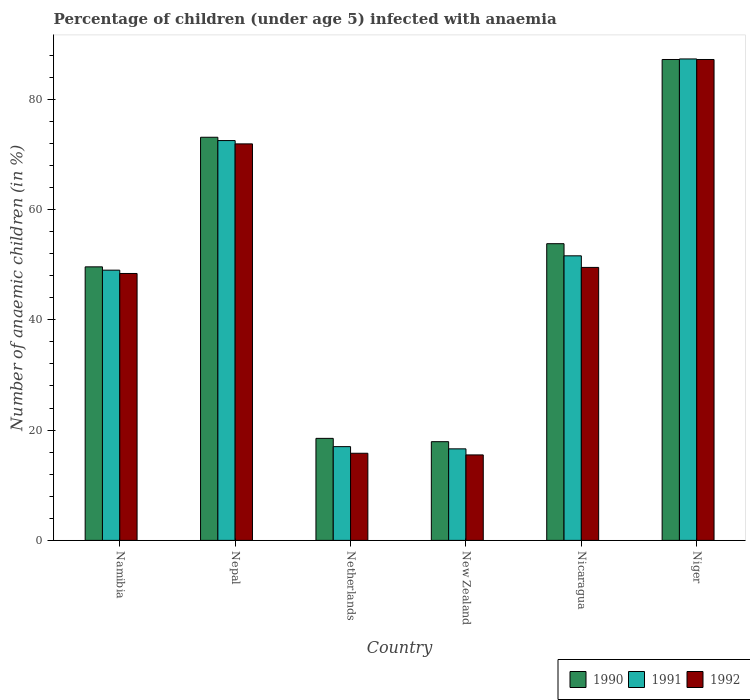How many different coloured bars are there?
Keep it short and to the point. 3. Are the number of bars on each tick of the X-axis equal?
Your answer should be compact. Yes. How many bars are there on the 6th tick from the left?
Offer a terse response. 3. What is the label of the 4th group of bars from the left?
Your answer should be very brief. New Zealand. Across all countries, what is the maximum percentage of children infected with anaemia in in 1992?
Ensure brevity in your answer.  87.2. Across all countries, what is the minimum percentage of children infected with anaemia in in 1992?
Ensure brevity in your answer.  15.5. In which country was the percentage of children infected with anaemia in in 1992 maximum?
Ensure brevity in your answer.  Niger. In which country was the percentage of children infected with anaemia in in 1991 minimum?
Your answer should be very brief. New Zealand. What is the total percentage of children infected with anaemia in in 1990 in the graph?
Offer a very short reply. 300.1. What is the difference between the percentage of children infected with anaemia in in 1991 in Nepal and that in Nicaragua?
Provide a succinct answer. 20.9. What is the difference between the percentage of children infected with anaemia in in 1990 in Nicaragua and the percentage of children infected with anaemia in in 1991 in Netherlands?
Keep it short and to the point. 36.8. What is the difference between the percentage of children infected with anaemia in of/in 1991 and percentage of children infected with anaemia in of/in 1990 in Netherlands?
Make the answer very short. -1.5. What is the ratio of the percentage of children infected with anaemia in in 1992 in Netherlands to that in Nicaragua?
Your answer should be very brief. 0.32. What is the difference between the highest and the second highest percentage of children infected with anaemia in in 1990?
Provide a succinct answer. 19.3. What is the difference between the highest and the lowest percentage of children infected with anaemia in in 1990?
Your answer should be compact. 69.3. In how many countries, is the percentage of children infected with anaemia in in 1990 greater than the average percentage of children infected with anaemia in in 1990 taken over all countries?
Provide a succinct answer. 3. Is the sum of the percentage of children infected with anaemia in in 1991 in Netherlands and New Zealand greater than the maximum percentage of children infected with anaemia in in 1992 across all countries?
Ensure brevity in your answer.  No. What does the 1st bar from the left in New Zealand represents?
Give a very brief answer. 1990. What does the 1st bar from the right in Namibia represents?
Your answer should be compact. 1992. Are all the bars in the graph horizontal?
Offer a very short reply. No. How many countries are there in the graph?
Your response must be concise. 6. What is the difference between two consecutive major ticks on the Y-axis?
Give a very brief answer. 20. Does the graph contain grids?
Your answer should be very brief. No. How are the legend labels stacked?
Offer a very short reply. Horizontal. What is the title of the graph?
Provide a short and direct response. Percentage of children (under age 5) infected with anaemia. What is the label or title of the Y-axis?
Your response must be concise. Number of anaemic children (in %). What is the Number of anaemic children (in %) of 1990 in Namibia?
Offer a terse response. 49.6. What is the Number of anaemic children (in %) in 1991 in Namibia?
Your answer should be compact. 49. What is the Number of anaemic children (in %) of 1992 in Namibia?
Your answer should be compact. 48.4. What is the Number of anaemic children (in %) of 1990 in Nepal?
Provide a short and direct response. 73.1. What is the Number of anaemic children (in %) of 1991 in Nepal?
Offer a terse response. 72.5. What is the Number of anaemic children (in %) in 1992 in Nepal?
Make the answer very short. 71.9. What is the Number of anaemic children (in %) of 1991 in Netherlands?
Make the answer very short. 17. What is the Number of anaemic children (in %) in 1992 in Netherlands?
Provide a succinct answer. 15.8. What is the Number of anaemic children (in %) in 1990 in New Zealand?
Provide a succinct answer. 17.9. What is the Number of anaemic children (in %) in 1992 in New Zealand?
Ensure brevity in your answer.  15.5. What is the Number of anaemic children (in %) of 1990 in Nicaragua?
Your answer should be very brief. 53.8. What is the Number of anaemic children (in %) in 1991 in Nicaragua?
Your response must be concise. 51.6. What is the Number of anaemic children (in %) of 1992 in Nicaragua?
Provide a succinct answer. 49.5. What is the Number of anaemic children (in %) in 1990 in Niger?
Keep it short and to the point. 87.2. What is the Number of anaemic children (in %) in 1991 in Niger?
Your answer should be compact. 87.3. What is the Number of anaemic children (in %) of 1992 in Niger?
Provide a succinct answer. 87.2. Across all countries, what is the maximum Number of anaemic children (in %) in 1990?
Provide a short and direct response. 87.2. Across all countries, what is the maximum Number of anaemic children (in %) in 1991?
Your answer should be compact. 87.3. Across all countries, what is the maximum Number of anaemic children (in %) in 1992?
Your answer should be very brief. 87.2. Across all countries, what is the minimum Number of anaemic children (in %) in 1991?
Keep it short and to the point. 16.6. What is the total Number of anaemic children (in %) of 1990 in the graph?
Provide a succinct answer. 300.1. What is the total Number of anaemic children (in %) of 1991 in the graph?
Keep it short and to the point. 294. What is the total Number of anaemic children (in %) in 1992 in the graph?
Your answer should be very brief. 288.3. What is the difference between the Number of anaemic children (in %) of 1990 in Namibia and that in Nepal?
Provide a succinct answer. -23.5. What is the difference between the Number of anaemic children (in %) of 1991 in Namibia and that in Nepal?
Keep it short and to the point. -23.5. What is the difference between the Number of anaemic children (in %) of 1992 in Namibia and that in Nepal?
Your answer should be compact. -23.5. What is the difference between the Number of anaemic children (in %) of 1990 in Namibia and that in Netherlands?
Your response must be concise. 31.1. What is the difference between the Number of anaemic children (in %) in 1992 in Namibia and that in Netherlands?
Your answer should be very brief. 32.6. What is the difference between the Number of anaemic children (in %) in 1990 in Namibia and that in New Zealand?
Provide a short and direct response. 31.7. What is the difference between the Number of anaemic children (in %) of 1991 in Namibia and that in New Zealand?
Offer a terse response. 32.4. What is the difference between the Number of anaemic children (in %) of 1992 in Namibia and that in New Zealand?
Ensure brevity in your answer.  32.9. What is the difference between the Number of anaemic children (in %) of 1991 in Namibia and that in Nicaragua?
Your response must be concise. -2.6. What is the difference between the Number of anaemic children (in %) in 1992 in Namibia and that in Nicaragua?
Ensure brevity in your answer.  -1.1. What is the difference between the Number of anaemic children (in %) of 1990 in Namibia and that in Niger?
Your response must be concise. -37.6. What is the difference between the Number of anaemic children (in %) in 1991 in Namibia and that in Niger?
Keep it short and to the point. -38.3. What is the difference between the Number of anaemic children (in %) of 1992 in Namibia and that in Niger?
Offer a terse response. -38.8. What is the difference between the Number of anaemic children (in %) in 1990 in Nepal and that in Netherlands?
Offer a terse response. 54.6. What is the difference between the Number of anaemic children (in %) in 1991 in Nepal and that in Netherlands?
Your response must be concise. 55.5. What is the difference between the Number of anaemic children (in %) of 1992 in Nepal and that in Netherlands?
Provide a succinct answer. 56.1. What is the difference between the Number of anaemic children (in %) in 1990 in Nepal and that in New Zealand?
Keep it short and to the point. 55.2. What is the difference between the Number of anaemic children (in %) in 1991 in Nepal and that in New Zealand?
Provide a short and direct response. 55.9. What is the difference between the Number of anaemic children (in %) in 1992 in Nepal and that in New Zealand?
Keep it short and to the point. 56.4. What is the difference between the Number of anaemic children (in %) in 1990 in Nepal and that in Nicaragua?
Provide a succinct answer. 19.3. What is the difference between the Number of anaemic children (in %) of 1991 in Nepal and that in Nicaragua?
Provide a succinct answer. 20.9. What is the difference between the Number of anaemic children (in %) of 1992 in Nepal and that in Nicaragua?
Provide a succinct answer. 22.4. What is the difference between the Number of anaemic children (in %) of 1990 in Nepal and that in Niger?
Your answer should be compact. -14.1. What is the difference between the Number of anaemic children (in %) in 1991 in Nepal and that in Niger?
Give a very brief answer. -14.8. What is the difference between the Number of anaemic children (in %) in 1992 in Nepal and that in Niger?
Offer a terse response. -15.3. What is the difference between the Number of anaemic children (in %) of 1990 in Netherlands and that in New Zealand?
Your response must be concise. 0.6. What is the difference between the Number of anaemic children (in %) in 1990 in Netherlands and that in Nicaragua?
Offer a terse response. -35.3. What is the difference between the Number of anaemic children (in %) in 1991 in Netherlands and that in Nicaragua?
Keep it short and to the point. -34.6. What is the difference between the Number of anaemic children (in %) of 1992 in Netherlands and that in Nicaragua?
Make the answer very short. -33.7. What is the difference between the Number of anaemic children (in %) in 1990 in Netherlands and that in Niger?
Your answer should be compact. -68.7. What is the difference between the Number of anaemic children (in %) of 1991 in Netherlands and that in Niger?
Ensure brevity in your answer.  -70.3. What is the difference between the Number of anaemic children (in %) of 1992 in Netherlands and that in Niger?
Give a very brief answer. -71.4. What is the difference between the Number of anaemic children (in %) of 1990 in New Zealand and that in Nicaragua?
Your answer should be compact. -35.9. What is the difference between the Number of anaemic children (in %) in 1991 in New Zealand and that in Nicaragua?
Your response must be concise. -35. What is the difference between the Number of anaemic children (in %) in 1992 in New Zealand and that in Nicaragua?
Keep it short and to the point. -34. What is the difference between the Number of anaemic children (in %) in 1990 in New Zealand and that in Niger?
Keep it short and to the point. -69.3. What is the difference between the Number of anaemic children (in %) in 1991 in New Zealand and that in Niger?
Provide a short and direct response. -70.7. What is the difference between the Number of anaemic children (in %) of 1992 in New Zealand and that in Niger?
Your answer should be very brief. -71.7. What is the difference between the Number of anaemic children (in %) of 1990 in Nicaragua and that in Niger?
Your answer should be very brief. -33.4. What is the difference between the Number of anaemic children (in %) of 1991 in Nicaragua and that in Niger?
Your response must be concise. -35.7. What is the difference between the Number of anaemic children (in %) in 1992 in Nicaragua and that in Niger?
Offer a very short reply. -37.7. What is the difference between the Number of anaemic children (in %) of 1990 in Namibia and the Number of anaemic children (in %) of 1991 in Nepal?
Provide a succinct answer. -22.9. What is the difference between the Number of anaemic children (in %) in 1990 in Namibia and the Number of anaemic children (in %) in 1992 in Nepal?
Keep it short and to the point. -22.3. What is the difference between the Number of anaemic children (in %) in 1991 in Namibia and the Number of anaemic children (in %) in 1992 in Nepal?
Make the answer very short. -22.9. What is the difference between the Number of anaemic children (in %) of 1990 in Namibia and the Number of anaemic children (in %) of 1991 in Netherlands?
Keep it short and to the point. 32.6. What is the difference between the Number of anaemic children (in %) in 1990 in Namibia and the Number of anaemic children (in %) in 1992 in Netherlands?
Offer a terse response. 33.8. What is the difference between the Number of anaemic children (in %) in 1991 in Namibia and the Number of anaemic children (in %) in 1992 in Netherlands?
Your answer should be compact. 33.2. What is the difference between the Number of anaemic children (in %) of 1990 in Namibia and the Number of anaemic children (in %) of 1992 in New Zealand?
Offer a terse response. 34.1. What is the difference between the Number of anaemic children (in %) in 1991 in Namibia and the Number of anaemic children (in %) in 1992 in New Zealand?
Ensure brevity in your answer.  33.5. What is the difference between the Number of anaemic children (in %) of 1990 in Namibia and the Number of anaemic children (in %) of 1991 in Nicaragua?
Keep it short and to the point. -2. What is the difference between the Number of anaemic children (in %) of 1990 in Namibia and the Number of anaemic children (in %) of 1991 in Niger?
Provide a succinct answer. -37.7. What is the difference between the Number of anaemic children (in %) of 1990 in Namibia and the Number of anaemic children (in %) of 1992 in Niger?
Provide a short and direct response. -37.6. What is the difference between the Number of anaemic children (in %) of 1991 in Namibia and the Number of anaemic children (in %) of 1992 in Niger?
Give a very brief answer. -38.2. What is the difference between the Number of anaemic children (in %) in 1990 in Nepal and the Number of anaemic children (in %) in 1991 in Netherlands?
Offer a very short reply. 56.1. What is the difference between the Number of anaemic children (in %) in 1990 in Nepal and the Number of anaemic children (in %) in 1992 in Netherlands?
Make the answer very short. 57.3. What is the difference between the Number of anaemic children (in %) in 1991 in Nepal and the Number of anaemic children (in %) in 1992 in Netherlands?
Give a very brief answer. 56.7. What is the difference between the Number of anaemic children (in %) of 1990 in Nepal and the Number of anaemic children (in %) of 1991 in New Zealand?
Your answer should be compact. 56.5. What is the difference between the Number of anaemic children (in %) in 1990 in Nepal and the Number of anaemic children (in %) in 1992 in New Zealand?
Keep it short and to the point. 57.6. What is the difference between the Number of anaemic children (in %) of 1991 in Nepal and the Number of anaemic children (in %) of 1992 in New Zealand?
Provide a short and direct response. 57. What is the difference between the Number of anaemic children (in %) of 1990 in Nepal and the Number of anaemic children (in %) of 1991 in Nicaragua?
Provide a short and direct response. 21.5. What is the difference between the Number of anaemic children (in %) of 1990 in Nepal and the Number of anaemic children (in %) of 1992 in Nicaragua?
Your response must be concise. 23.6. What is the difference between the Number of anaemic children (in %) in 1991 in Nepal and the Number of anaemic children (in %) in 1992 in Nicaragua?
Offer a terse response. 23. What is the difference between the Number of anaemic children (in %) in 1990 in Nepal and the Number of anaemic children (in %) in 1992 in Niger?
Make the answer very short. -14.1. What is the difference between the Number of anaemic children (in %) in 1991 in Nepal and the Number of anaemic children (in %) in 1992 in Niger?
Your response must be concise. -14.7. What is the difference between the Number of anaemic children (in %) of 1990 in Netherlands and the Number of anaemic children (in %) of 1992 in New Zealand?
Provide a short and direct response. 3. What is the difference between the Number of anaemic children (in %) in 1991 in Netherlands and the Number of anaemic children (in %) in 1992 in New Zealand?
Your response must be concise. 1.5. What is the difference between the Number of anaemic children (in %) in 1990 in Netherlands and the Number of anaemic children (in %) in 1991 in Nicaragua?
Keep it short and to the point. -33.1. What is the difference between the Number of anaemic children (in %) in 1990 in Netherlands and the Number of anaemic children (in %) in 1992 in Nicaragua?
Your answer should be very brief. -31. What is the difference between the Number of anaemic children (in %) in 1991 in Netherlands and the Number of anaemic children (in %) in 1992 in Nicaragua?
Provide a succinct answer. -32.5. What is the difference between the Number of anaemic children (in %) in 1990 in Netherlands and the Number of anaemic children (in %) in 1991 in Niger?
Provide a succinct answer. -68.8. What is the difference between the Number of anaemic children (in %) of 1990 in Netherlands and the Number of anaemic children (in %) of 1992 in Niger?
Make the answer very short. -68.7. What is the difference between the Number of anaemic children (in %) in 1991 in Netherlands and the Number of anaemic children (in %) in 1992 in Niger?
Ensure brevity in your answer.  -70.2. What is the difference between the Number of anaemic children (in %) of 1990 in New Zealand and the Number of anaemic children (in %) of 1991 in Nicaragua?
Offer a terse response. -33.7. What is the difference between the Number of anaemic children (in %) of 1990 in New Zealand and the Number of anaemic children (in %) of 1992 in Nicaragua?
Make the answer very short. -31.6. What is the difference between the Number of anaemic children (in %) of 1991 in New Zealand and the Number of anaemic children (in %) of 1992 in Nicaragua?
Provide a succinct answer. -32.9. What is the difference between the Number of anaemic children (in %) of 1990 in New Zealand and the Number of anaemic children (in %) of 1991 in Niger?
Your answer should be very brief. -69.4. What is the difference between the Number of anaemic children (in %) in 1990 in New Zealand and the Number of anaemic children (in %) in 1992 in Niger?
Your answer should be compact. -69.3. What is the difference between the Number of anaemic children (in %) in 1991 in New Zealand and the Number of anaemic children (in %) in 1992 in Niger?
Keep it short and to the point. -70.6. What is the difference between the Number of anaemic children (in %) of 1990 in Nicaragua and the Number of anaemic children (in %) of 1991 in Niger?
Provide a succinct answer. -33.5. What is the difference between the Number of anaemic children (in %) in 1990 in Nicaragua and the Number of anaemic children (in %) in 1992 in Niger?
Offer a very short reply. -33.4. What is the difference between the Number of anaemic children (in %) in 1991 in Nicaragua and the Number of anaemic children (in %) in 1992 in Niger?
Your answer should be very brief. -35.6. What is the average Number of anaemic children (in %) of 1990 per country?
Provide a short and direct response. 50.02. What is the average Number of anaemic children (in %) in 1992 per country?
Make the answer very short. 48.05. What is the difference between the Number of anaemic children (in %) in 1990 and Number of anaemic children (in %) in 1991 in Namibia?
Make the answer very short. 0.6. What is the difference between the Number of anaemic children (in %) of 1990 and Number of anaemic children (in %) of 1992 in Namibia?
Provide a succinct answer. 1.2. What is the difference between the Number of anaemic children (in %) of 1991 and Number of anaemic children (in %) of 1992 in Namibia?
Provide a short and direct response. 0.6. What is the difference between the Number of anaemic children (in %) of 1990 and Number of anaemic children (in %) of 1992 in Nepal?
Provide a succinct answer. 1.2. What is the difference between the Number of anaemic children (in %) in 1990 and Number of anaemic children (in %) in 1991 in Netherlands?
Your answer should be very brief. 1.5. What is the difference between the Number of anaemic children (in %) in 1990 and Number of anaemic children (in %) in 1991 in New Zealand?
Keep it short and to the point. 1.3. What is the difference between the Number of anaemic children (in %) in 1991 and Number of anaemic children (in %) in 1992 in New Zealand?
Your response must be concise. 1.1. What is the difference between the Number of anaemic children (in %) of 1990 and Number of anaemic children (in %) of 1991 in Nicaragua?
Offer a terse response. 2.2. What is the difference between the Number of anaemic children (in %) of 1990 and Number of anaemic children (in %) of 1991 in Niger?
Provide a succinct answer. -0.1. What is the difference between the Number of anaemic children (in %) in 1990 and Number of anaemic children (in %) in 1992 in Niger?
Ensure brevity in your answer.  0. What is the ratio of the Number of anaemic children (in %) in 1990 in Namibia to that in Nepal?
Your response must be concise. 0.68. What is the ratio of the Number of anaemic children (in %) in 1991 in Namibia to that in Nepal?
Offer a very short reply. 0.68. What is the ratio of the Number of anaemic children (in %) of 1992 in Namibia to that in Nepal?
Your response must be concise. 0.67. What is the ratio of the Number of anaemic children (in %) of 1990 in Namibia to that in Netherlands?
Provide a succinct answer. 2.68. What is the ratio of the Number of anaemic children (in %) of 1991 in Namibia to that in Netherlands?
Give a very brief answer. 2.88. What is the ratio of the Number of anaemic children (in %) of 1992 in Namibia to that in Netherlands?
Keep it short and to the point. 3.06. What is the ratio of the Number of anaemic children (in %) of 1990 in Namibia to that in New Zealand?
Provide a succinct answer. 2.77. What is the ratio of the Number of anaemic children (in %) in 1991 in Namibia to that in New Zealand?
Your response must be concise. 2.95. What is the ratio of the Number of anaemic children (in %) in 1992 in Namibia to that in New Zealand?
Ensure brevity in your answer.  3.12. What is the ratio of the Number of anaemic children (in %) of 1990 in Namibia to that in Nicaragua?
Offer a very short reply. 0.92. What is the ratio of the Number of anaemic children (in %) in 1991 in Namibia to that in Nicaragua?
Provide a short and direct response. 0.95. What is the ratio of the Number of anaemic children (in %) of 1992 in Namibia to that in Nicaragua?
Offer a terse response. 0.98. What is the ratio of the Number of anaemic children (in %) in 1990 in Namibia to that in Niger?
Make the answer very short. 0.57. What is the ratio of the Number of anaemic children (in %) of 1991 in Namibia to that in Niger?
Give a very brief answer. 0.56. What is the ratio of the Number of anaemic children (in %) of 1992 in Namibia to that in Niger?
Ensure brevity in your answer.  0.56. What is the ratio of the Number of anaemic children (in %) in 1990 in Nepal to that in Netherlands?
Give a very brief answer. 3.95. What is the ratio of the Number of anaemic children (in %) in 1991 in Nepal to that in Netherlands?
Give a very brief answer. 4.26. What is the ratio of the Number of anaemic children (in %) in 1992 in Nepal to that in Netherlands?
Offer a terse response. 4.55. What is the ratio of the Number of anaemic children (in %) in 1990 in Nepal to that in New Zealand?
Provide a short and direct response. 4.08. What is the ratio of the Number of anaemic children (in %) of 1991 in Nepal to that in New Zealand?
Your response must be concise. 4.37. What is the ratio of the Number of anaemic children (in %) in 1992 in Nepal to that in New Zealand?
Your answer should be compact. 4.64. What is the ratio of the Number of anaemic children (in %) of 1990 in Nepal to that in Nicaragua?
Make the answer very short. 1.36. What is the ratio of the Number of anaemic children (in %) of 1991 in Nepal to that in Nicaragua?
Provide a short and direct response. 1.41. What is the ratio of the Number of anaemic children (in %) of 1992 in Nepal to that in Nicaragua?
Ensure brevity in your answer.  1.45. What is the ratio of the Number of anaemic children (in %) of 1990 in Nepal to that in Niger?
Your response must be concise. 0.84. What is the ratio of the Number of anaemic children (in %) of 1991 in Nepal to that in Niger?
Give a very brief answer. 0.83. What is the ratio of the Number of anaemic children (in %) of 1992 in Nepal to that in Niger?
Your answer should be compact. 0.82. What is the ratio of the Number of anaemic children (in %) in 1990 in Netherlands to that in New Zealand?
Give a very brief answer. 1.03. What is the ratio of the Number of anaemic children (in %) of 1991 in Netherlands to that in New Zealand?
Offer a terse response. 1.02. What is the ratio of the Number of anaemic children (in %) in 1992 in Netherlands to that in New Zealand?
Offer a very short reply. 1.02. What is the ratio of the Number of anaemic children (in %) of 1990 in Netherlands to that in Nicaragua?
Offer a terse response. 0.34. What is the ratio of the Number of anaemic children (in %) in 1991 in Netherlands to that in Nicaragua?
Provide a succinct answer. 0.33. What is the ratio of the Number of anaemic children (in %) in 1992 in Netherlands to that in Nicaragua?
Provide a short and direct response. 0.32. What is the ratio of the Number of anaemic children (in %) in 1990 in Netherlands to that in Niger?
Ensure brevity in your answer.  0.21. What is the ratio of the Number of anaemic children (in %) in 1991 in Netherlands to that in Niger?
Offer a very short reply. 0.19. What is the ratio of the Number of anaemic children (in %) of 1992 in Netherlands to that in Niger?
Your answer should be compact. 0.18. What is the ratio of the Number of anaemic children (in %) of 1990 in New Zealand to that in Nicaragua?
Provide a succinct answer. 0.33. What is the ratio of the Number of anaemic children (in %) of 1991 in New Zealand to that in Nicaragua?
Your answer should be compact. 0.32. What is the ratio of the Number of anaemic children (in %) in 1992 in New Zealand to that in Nicaragua?
Your answer should be compact. 0.31. What is the ratio of the Number of anaemic children (in %) of 1990 in New Zealand to that in Niger?
Your response must be concise. 0.21. What is the ratio of the Number of anaemic children (in %) of 1991 in New Zealand to that in Niger?
Keep it short and to the point. 0.19. What is the ratio of the Number of anaemic children (in %) of 1992 in New Zealand to that in Niger?
Provide a short and direct response. 0.18. What is the ratio of the Number of anaemic children (in %) of 1990 in Nicaragua to that in Niger?
Offer a terse response. 0.62. What is the ratio of the Number of anaemic children (in %) of 1991 in Nicaragua to that in Niger?
Offer a terse response. 0.59. What is the ratio of the Number of anaemic children (in %) in 1992 in Nicaragua to that in Niger?
Keep it short and to the point. 0.57. What is the difference between the highest and the second highest Number of anaemic children (in %) in 1990?
Give a very brief answer. 14.1. What is the difference between the highest and the lowest Number of anaemic children (in %) of 1990?
Ensure brevity in your answer.  69.3. What is the difference between the highest and the lowest Number of anaemic children (in %) in 1991?
Your response must be concise. 70.7. What is the difference between the highest and the lowest Number of anaemic children (in %) in 1992?
Keep it short and to the point. 71.7. 